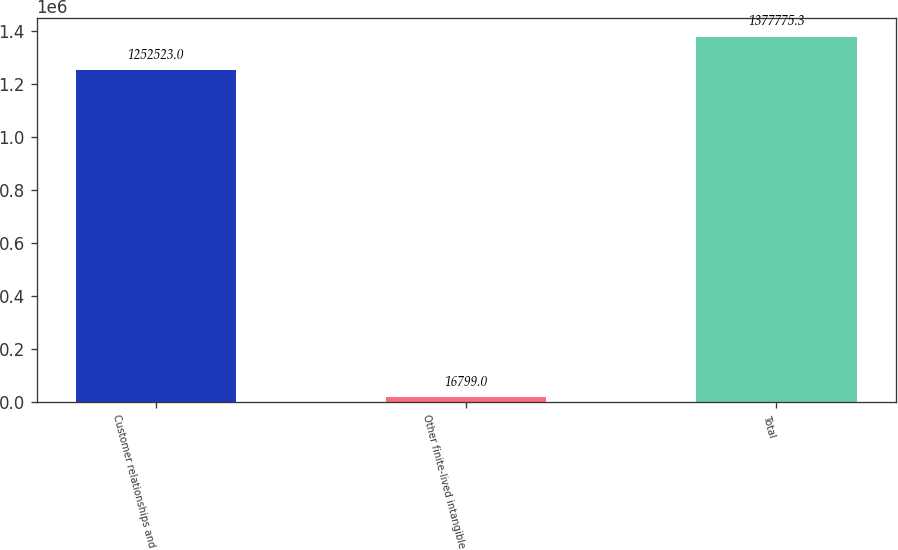Convert chart to OTSL. <chart><loc_0><loc_0><loc_500><loc_500><bar_chart><fcel>Customer relationships and<fcel>Other finite-lived intangible<fcel>Total<nl><fcel>1.25252e+06<fcel>16799<fcel>1.37778e+06<nl></chart> 